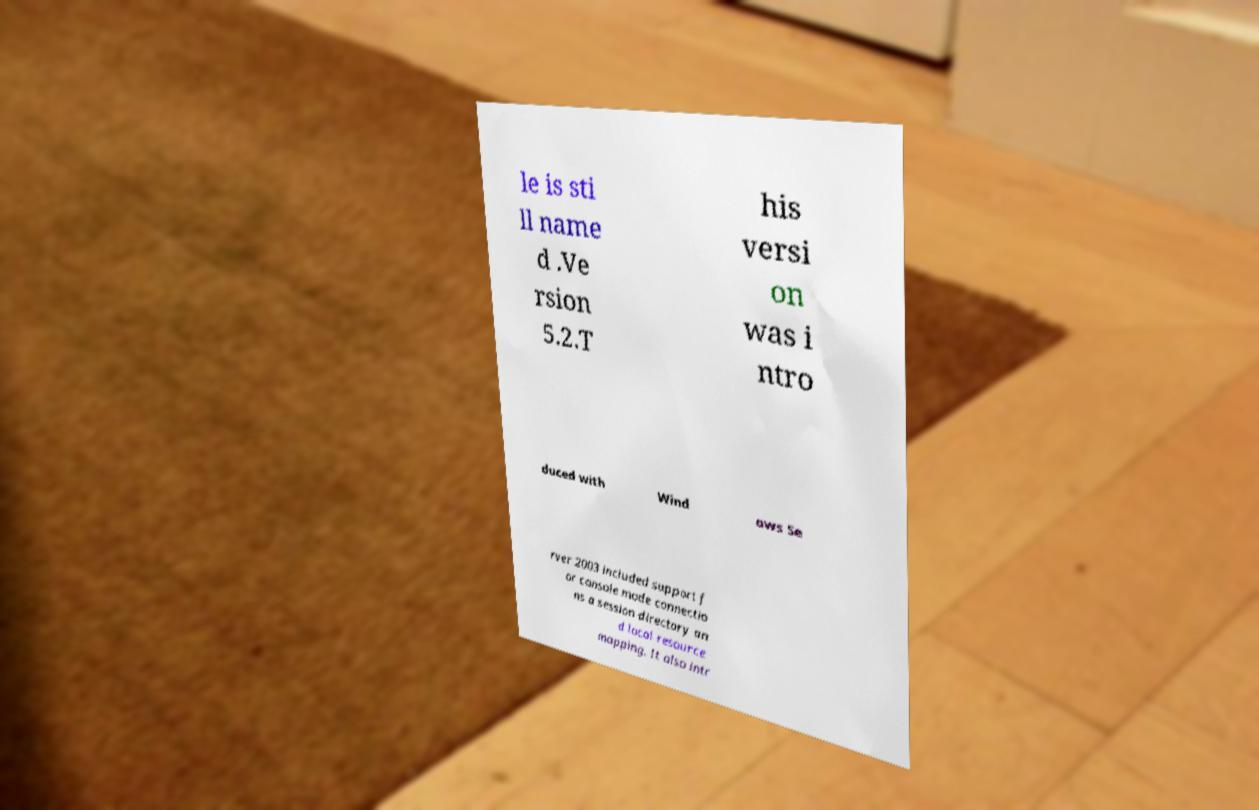Can you accurately transcribe the text from the provided image for me? le is sti ll name d .Ve rsion 5.2.T his versi on was i ntro duced with Wind ows Se rver 2003 included support f or console mode connectio ns a session directory an d local resource mapping. It also intr 